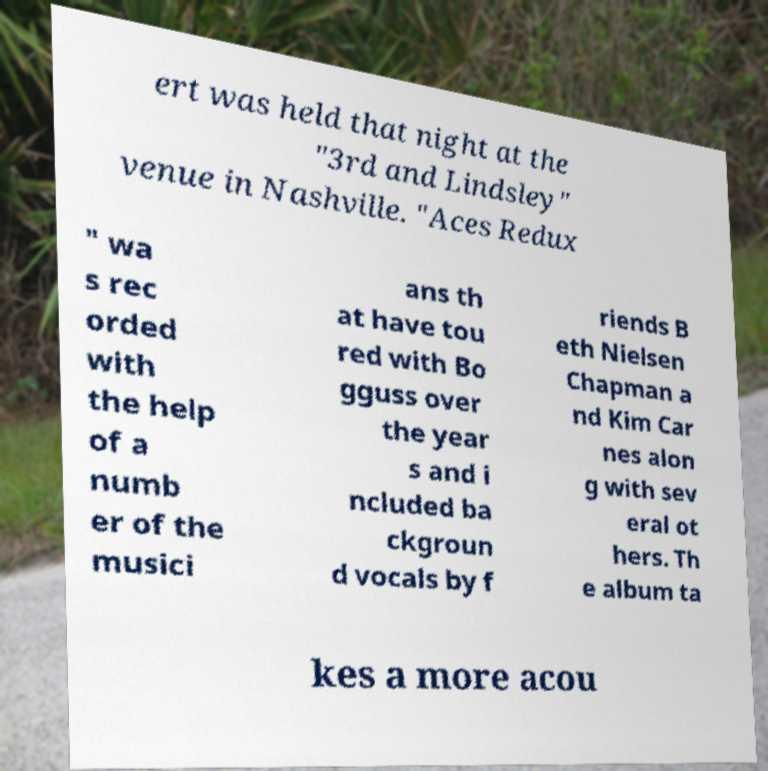Please identify and transcribe the text found in this image. ert was held that night at the "3rd and Lindsley" venue in Nashville. "Aces Redux " wa s rec orded with the help of a numb er of the musici ans th at have tou red with Bo gguss over the year s and i ncluded ba ckgroun d vocals by f riends B eth Nielsen Chapman a nd Kim Car nes alon g with sev eral ot hers. Th e album ta kes a more acou 